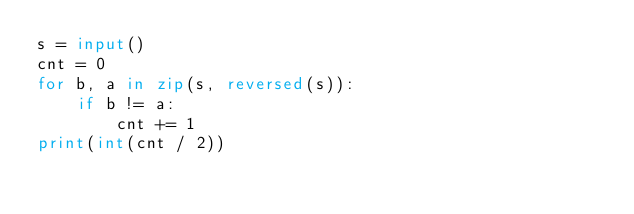Convert code to text. <code><loc_0><loc_0><loc_500><loc_500><_Python_>s = input()
cnt = 0
for b, a in zip(s, reversed(s)):
	if b != a:
		cnt += 1
print(int(cnt / 2))</code> 